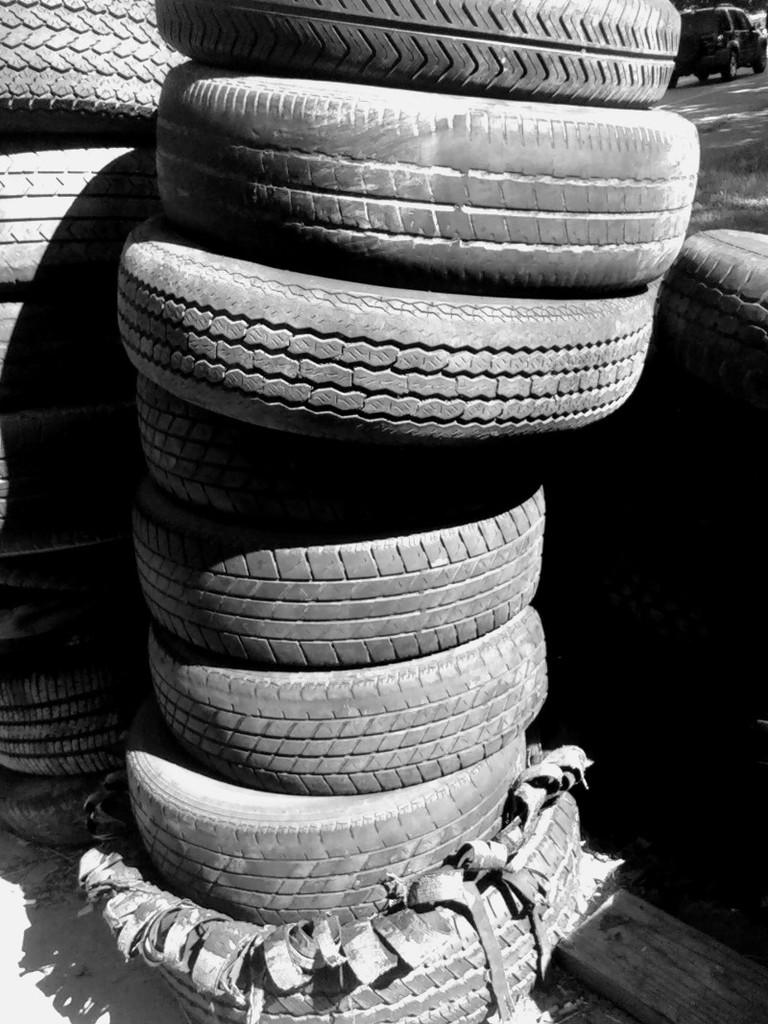What type of objects can be seen in the image? There are tyres and some other objects in the image. Can you describe the vehicle visible in the background of the image? The vehicle is visible in the background of the image, and it is on the ground. What is the cause of the alarm going off in the image? There is no alarm present in the image, so it is not possible to determine the cause of any alarm going off. 